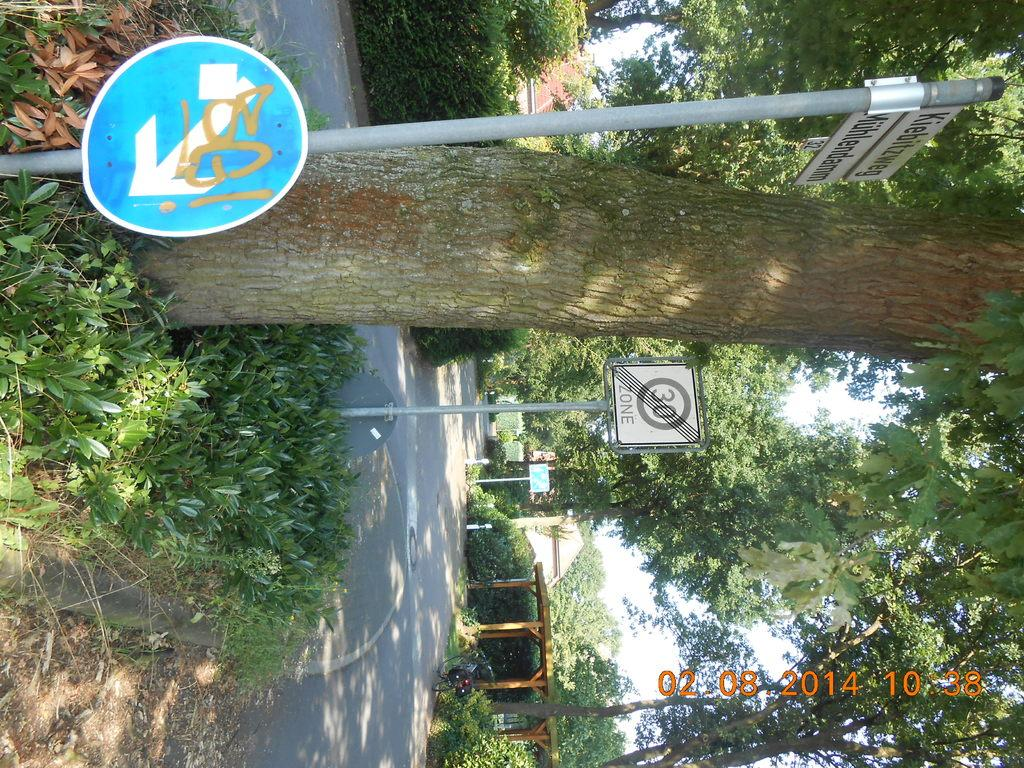<image>
Describe the image concisely. A street with some trees and sign to advise drivers that it is a 30 zone. 